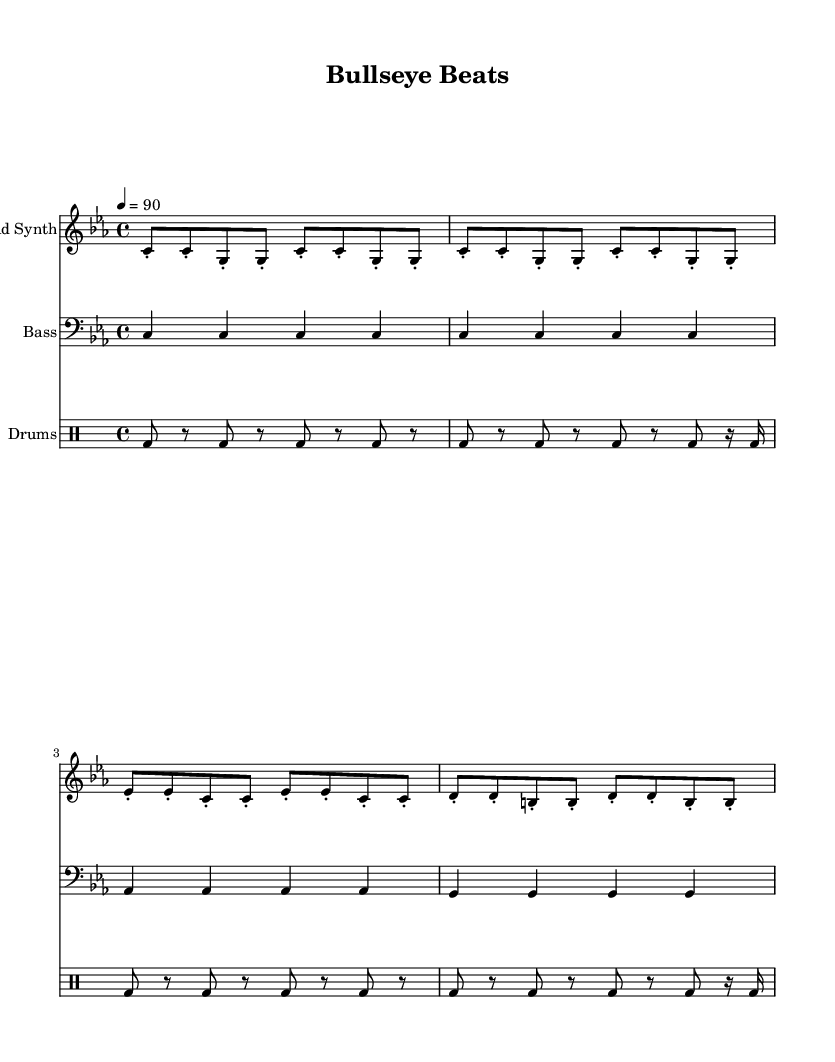What is the key signature of this music? The key signature is C minor, which has three flats (B♭, E♭, and A♭). This can be identified from the key signature symbol at the beginning of the staff.
Answer: C minor What is the time signature of this music? The time signature is 4/4, indicated at the beginning of the score. It shows that there are four beats in each measure, and the quarter note gets one beat.
Answer: 4/4 What is the tempo of this music? The tempo is indicated as 4 equals 90, which signifies the speed at which the music should be played. This means each quarter note should be played at a speed of 90 beats per minute.
Answer: 90 How many measures does the lead synth part have? By counting the groups of notes in the lead synth staff, we see there are eight measures present in total. This is determined by the vertical bars separating each measure.
Answer: 8 What type of drum is primarily used in this track? The drum part specifically indicates the bass drum (bd) throughout the measures. The repetitive usage of "bd" signifies that the focus is primarily on this type of drum.
Answer: bass drum What is the overall theme of the lyrics? The lyrics focus on precision and accuracy, as indicated by phrases like "Aim steady" and "Bullseye vision." This thematic content is aligned with the imagery of target shooting and is reflected in the music's rhythmic delivery.
Answer: target shooting How does the bass part relate to the lead synth part? The bass part complements the lead synth by reinforcing the foundational harmony in the key of C minor, creating a full sound typical in Hip Hop music. This harmonic relationship supports the melody articulated by the lead synth.
Answer: harmonic support 